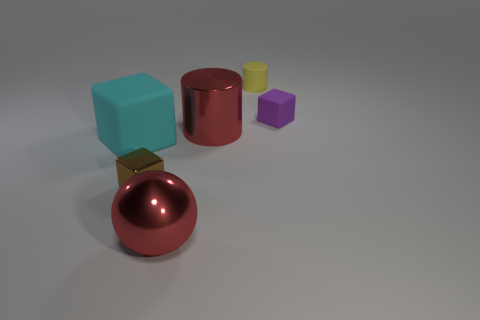What shape is the other small object that is made of the same material as the yellow thing?
Your answer should be very brief. Cube. Is the number of red spheres that are left of the large matte cube the same as the number of small red objects?
Your response must be concise. Yes. Is the material of the big object in front of the brown object the same as the small block that is on the right side of the yellow rubber cylinder?
Offer a very short reply. No. There is a purple object behind the red thing behind the cyan matte block; what is its shape?
Your answer should be very brief. Cube. What color is the big thing that is the same material as the small cylinder?
Your response must be concise. Cyan. Does the big metallic cylinder have the same color as the big sphere?
Offer a very short reply. Yes. There is a cyan rubber thing that is the same size as the red metallic cylinder; what is its shape?
Your response must be concise. Cube. What is the size of the yellow matte cylinder?
Give a very brief answer. Small. There is a rubber block behind the cyan object; is its size the same as the red object that is behind the cyan cube?
Your response must be concise. No. What is the color of the shiny cylinder that is on the left side of the tiny matte thing that is on the left side of the purple matte object?
Ensure brevity in your answer.  Red. 